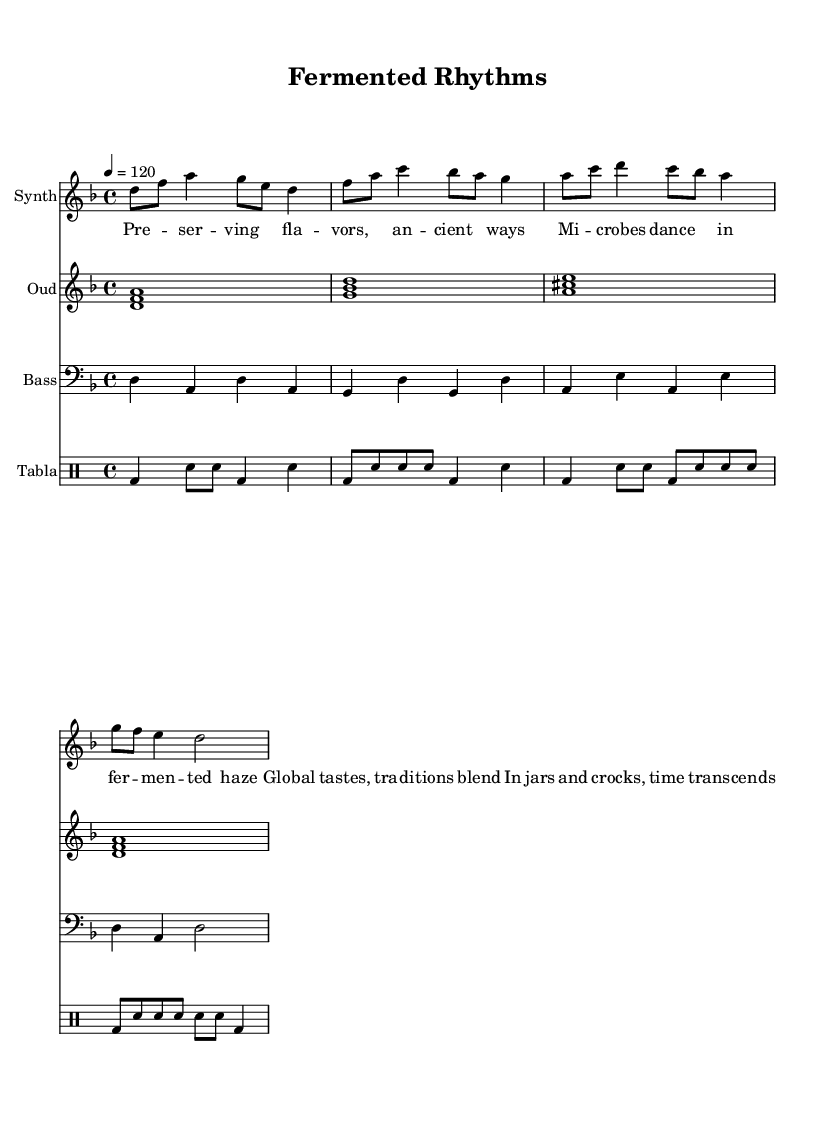What is the key signature of this music? The key signature is indicated at the beginning of the staff, showing two flats, which signifies that the piece is in D minor.
Answer: D minor What is the time signature of this music? The time signature is shown at the beginning of the piece as 4/4, meaning there are four beats per measure and the quarter note gets one beat.
Answer: 4/4 What is the tempo of this music? The tempo is marked in beats per minute, indicated as 4 = 120, meaning that each quarter note is played at a pace of 120 beats per minute.
Answer: 120 How many measures are there in the synth melody? By counting the lines and the number of measures written in the synth melody section, there are eight distinct measures provided.
Answer: 8 Which instruments are used alongside the synth melody? The score presents four distinct instruments: a synth, oud, bass, and tabla, specified in the staff format, each with its designated notation.
Answer: Synth, Oud, Bass, Tabla What kind of thematic techniques are referenced in the lyrics? The lyrics discuss preservation methods and cultural traditions related to food and fermentation, which aligns with the fusion aspect of world music elements.
Answer: Food preservation, fermentation What rhythmic pattern is used in the tabla part? In analyzing the tabla rhythm notated, the pattern consists of a sequence of bass drum (bd) and snare (sn) notes arranged in varying durations that create a complex rhythmic texture.
Answer: Bass and snare pattern 